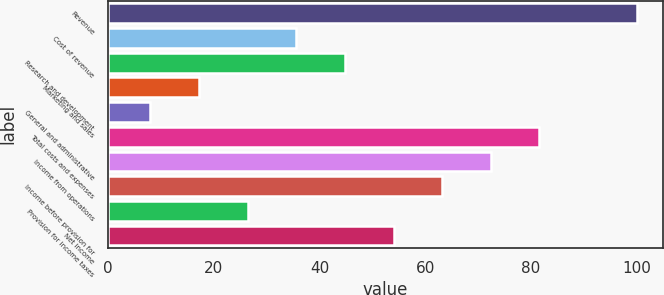Convert chart to OTSL. <chart><loc_0><loc_0><loc_500><loc_500><bar_chart><fcel>Revenue<fcel>Cost of revenue<fcel>Research and development<fcel>Marketing and sales<fcel>General and administrative<fcel>Total costs and expenses<fcel>Income from operations<fcel>Income before provision for<fcel>Provision for income taxes<fcel>Net income<nl><fcel>100<fcel>35.6<fcel>44.8<fcel>17.2<fcel>8<fcel>81.6<fcel>72.4<fcel>63.2<fcel>26.4<fcel>54<nl></chart> 